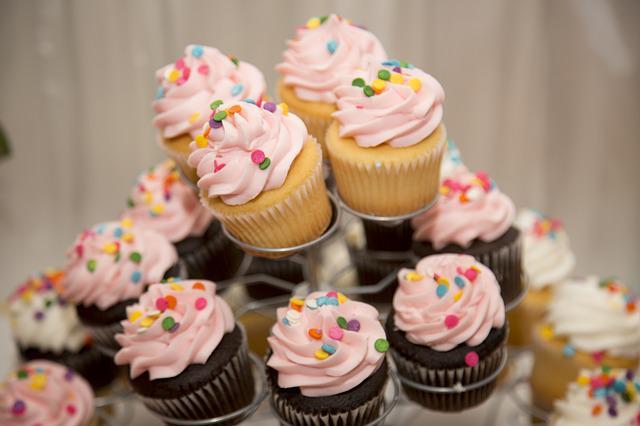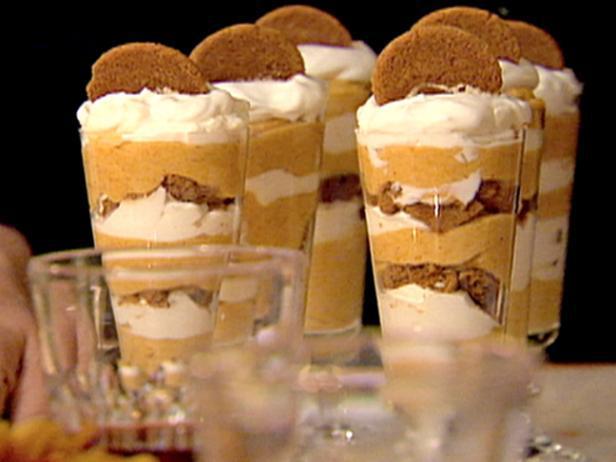The first image is the image on the left, the second image is the image on the right. Given the left and right images, does the statement "There are four glasses of a whipped cream topped dessert in one of the images." hold true? Answer yes or no. No. The first image is the image on the left, the second image is the image on the right. For the images shown, is this caption "All of the desserts shown have some type of fruit on top." true? Answer yes or no. No. 